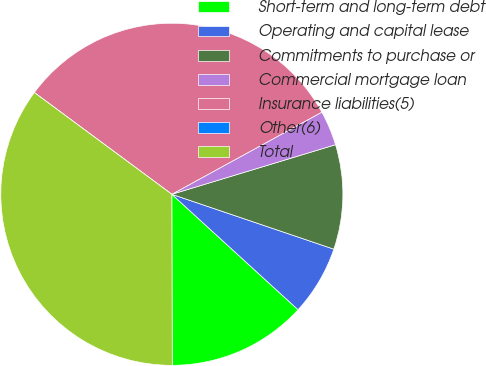Convert chart. <chart><loc_0><loc_0><loc_500><loc_500><pie_chart><fcel>Short-term and long-term debt<fcel>Operating and capital lease<fcel>Commitments to purchase or<fcel>Commercial mortgage loan<fcel>Insurance liabilities(5)<fcel>Other(6)<fcel>Total<nl><fcel>13.17%<fcel>6.59%<fcel>9.88%<fcel>3.29%<fcel>31.89%<fcel>0.0%<fcel>35.18%<nl></chart> 